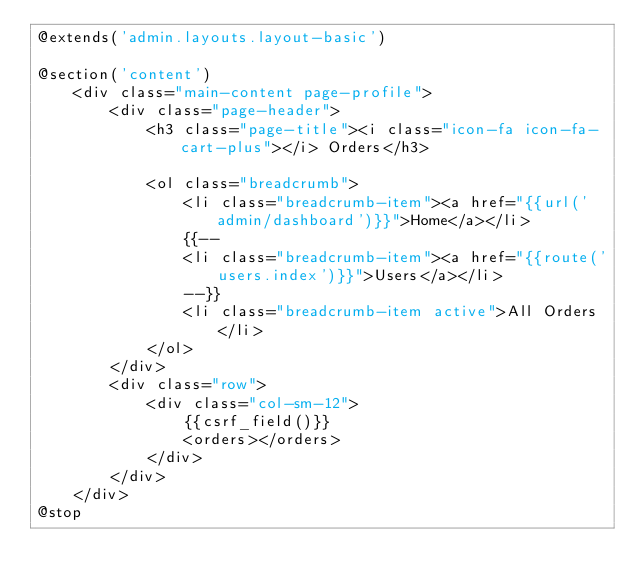<code> <loc_0><loc_0><loc_500><loc_500><_PHP_>@extends('admin.layouts.layout-basic')

@section('content')
    <div class="main-content page-profile">
        <div class="page-header">
            <h3 class="page-title"><i class="icon-fa icon-fa-cart-plus"></i> Orders</h3>

            <ol class="breadcrumb">
                <li class="breadcrumb-item"><a href="{{url('admin/dashboard')}}">Home</a></li>
                {{--
                <li class="breadcrumb-item"><a href="{{route('users.index')}}">Users</a></li>
                --}}
                <li class="breadcrumb-item active">All Orders</li>
            </ol>
        </div>
        <div class="row">
            <div class="col-sm-12">
                {{csrf_field()}}
                <orders></orders>
            </div>
        </div>
    </div>
@stop
</code> 